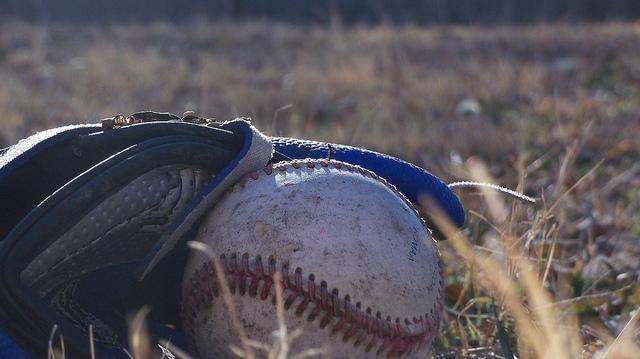How many people are jumping into the air?
Give a very brief answer. 0. 